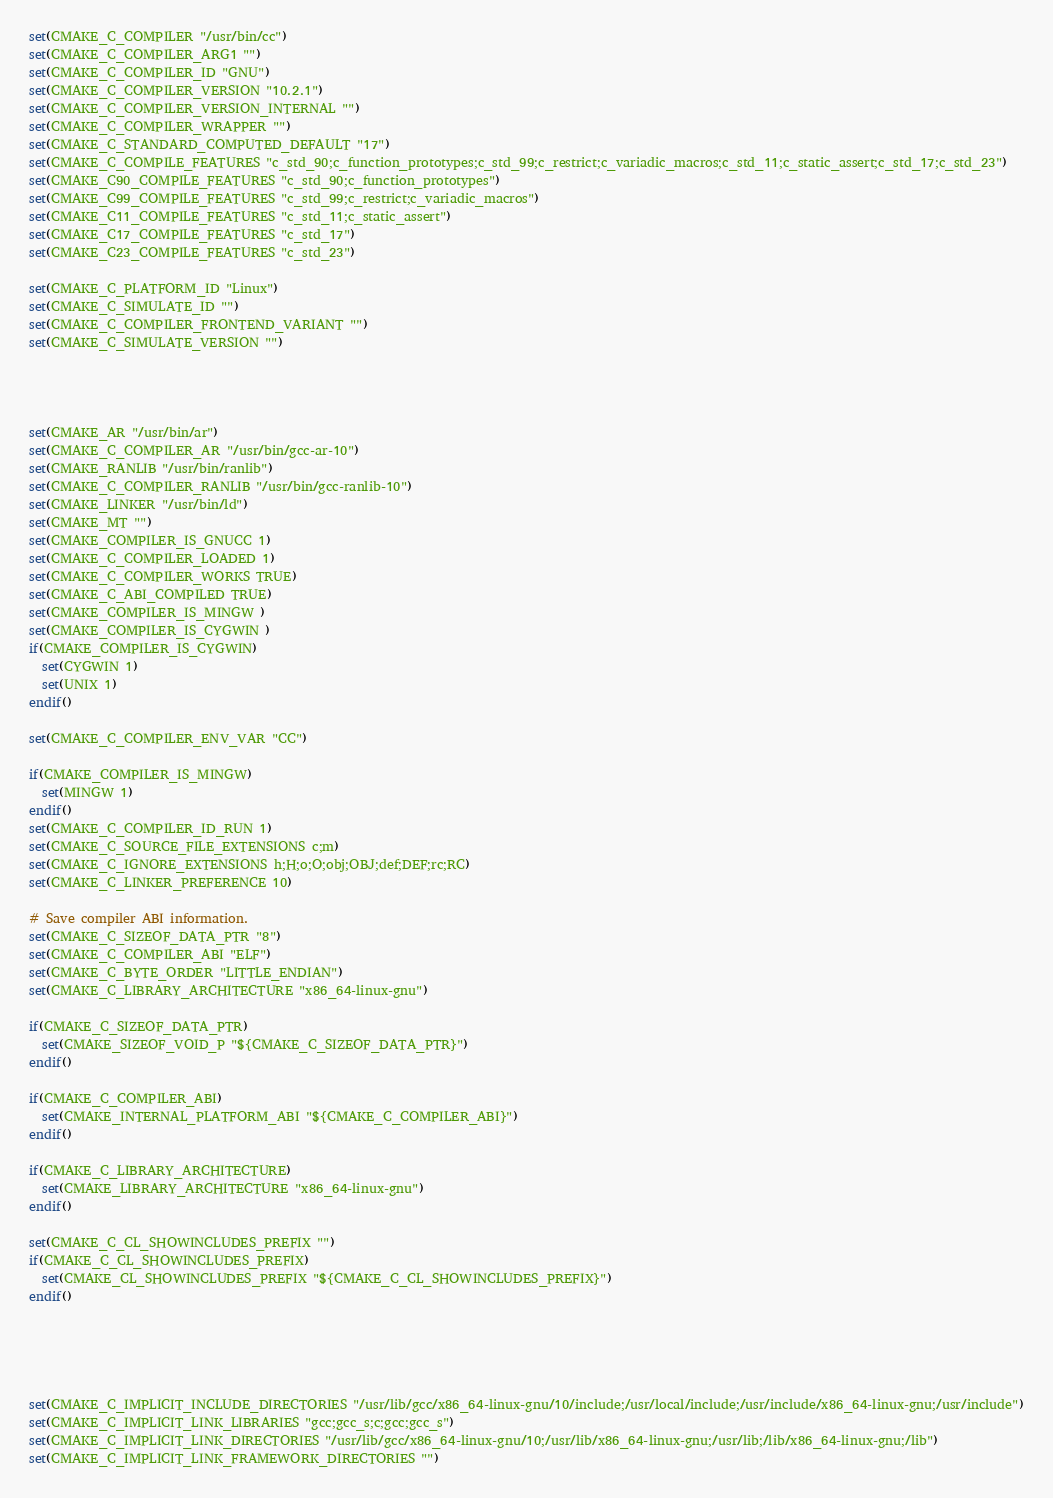<code> <loc_0><loc_0><loc_500><loc_500><_CMake_>set(CMAKE_C_COMPILER "/usr/bin/cc")
set(CMAKE_C_COMPILER_ARG1 "")
set(CMAKE_C_COMPILER_ID "GNU")
set(CMAKE_C_COMPILER_VERSION "10.2.1")
set(CMAKE_C_COMPILER_VERSION_INTERNAL "")
set(CMAKE_C_COMPILER_WRAPPER "")
set(CMAKE_C_STANDARD_COMPUTED_DEFAULT "17")
set(CMAKE_C_COMPILE_FEATURES "c_std_90;c_function_prototypes;c_std_99;c_restrict;c_variadic_macros;c_std_11;c_static_assert;c_std_17;c_std_23")
set(CMAKE_C90_COMPILE_FEATURES "c_std_90;c_function_prototypes")
set(CMAKE_C99_COMPILE_FEATURES "c_std_99;c_restrict;c_variadic_macros")
set(CMAKE_C11_COMPILE_FEATURES "c_std_11;c_static_assert")
set(CMAKE_C17_COMPILE_FEATURES "c_std_17")
set(CMAKE_C23_COMPILE_FEATURES "c_std_23")

set(CMAKE_C_PLATFORM_ID "Linux")
set(CMAKE_C_SIMULATE_ID "")
set(CMAKE_C_COMPILER_FRONTEND_VARIANT "")
set(CMAKE_C_SIMULATE_VERSION "")




set(CMAKE_AR "/usr/bin/ar")
set(CMAKE_C_COMPILER_AR "/usr/bin/gcc-ar-10")
set(CMAKE_RANLIB "/usr/bin/ranlib")
set(CMAKE_C_COMPILER_RANLIB "/usr/bin/gcc-ranlib-10")
set(CMAKE_LINKER "/usr/bin/ld")
set(CMAKE_MT "")
set(CMAKE_COMPILER_IS_GNUCC 1)
set(CMAKE_C_COMPILER_LOADED 1)
set(CMAKE_C_COMPILER_WORKS TRUE)
set(CMAKE_C_ABI_COMPILED TRUE)
set(CMAKE_COMPILER_IS_MINGW )
set(CMAKE_COMPILER_IS_CYGWIN )
if(CMAKE_COMPILER_IS_CYGWIN)
  set(CYGWIN 1)
  set(UNIX 1)
endif()

set(CMAKE_C_COMPILER_ENV_VAR "CC")

if(CMAKE_COMPILER_IS_MINGW)
  set(MINGW 1)
endif()
set(CMAKE_C_COMPILER_ID_RUN 1)
set(CMAKE_C_SOURCE_FILE_EXTENSIONS c;m)
set(CMAKE_C_IGNORE_EXTENSIONS h;H;o;O;obj;OBJ;def;DEF;rc;RC)
set(CMAKE_C_LINKER_PREFERENCE 10)

# Save compiler ABI information.
set(CMAKE_C_SIZEOF_DATA_PTR "8")
set(CMAKE_C_COMPILER_ABI "ELF")
set(CMAKE_C_BYTE_ORDER "LITTLE_ENDIAN")
set(CMAKE_C_LIBRARY_ARCHITECTURE "x86_64-linux-gnu")

if(CMAKE_C_SIZEOF_DATA_PTR)
  set(CMAKE_SIZEOF_VOID_P "${CMAKE_C_SIZEOF_DATA_PTR}")
endif()

if(CMAKE_C_COMPILER_ABI)
  set(CMAKE_INTERNAL_PLATFORM_ABI "${CMAKE_C_COMPILER_ABI}")
endif()

if(CMAKE_C_LIBRARY_ARCHITECTURE)
  set(CMAKE_LIBRARY_ARCHITECTURE "x86_64-linux-gnu")
endif()

set(CMAKE_C_CL_SHOWINCLUDES_PREFIX "")
if(CMAKE_C_CL_SHOWINCLUDES_PREFIX)
  set(CMAKE_CL_SHOWINCLUDES_PREFIX "${CMAKE_C_CL_SHOWINCLUDES_PREFIX}")
endif()





set(CMAKE_C_IMPLICIT_INCLUDE_DIRECTORIES "/usr/lib/gcc/x86_64-linux-gnu/10/include;/usr/local/include;/usr/include/x86_64-linux-gnu;/usr/include")
set(CMAKE_C_IMPLICIT_LINK_LIBRARIES "gcc;gcc_s;c;gcc;gcc_s")
set(CMAKE_C_IMPLICIT_LINK_DIRECTORIES "/usr/lib/gcc/x86_64-linux-gnu/10;/usr/lib/x86_64-linux-gnu;/usr/lib;/lib/x86_64-linux-gnu;/lib")
set(CMAKE_C_IMPLICIT_LINK_FRAMEWORK_DIRECTORIES "")
</code> 